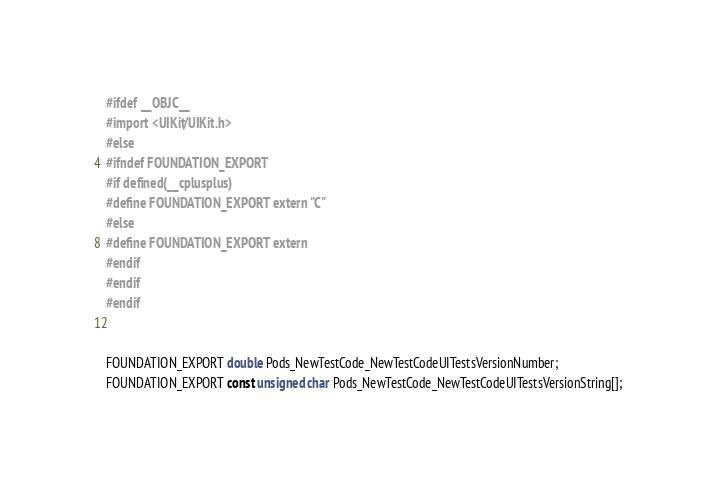Convert code to text. <code><loc_0><loc_0><loc_500><loc_500><_C_>#ifdef __OBJC__
#import <UIKit/UIKit.h>
#else
#ifndef FOUNDATION_EXPORT
#if defined(__cplusplus)
#define FOUNDATION_EXPORT extern "C"
#else
#define FOUNDATION_EXPORT extern
#endif
#endif
#endif


FOUNDATION_EXPORT double Pods_NewTestCode_NewTestCodeUITestsVersionNumber;
FOUNDATION_EXPORT const unsigned char Pods_NewTestCode_NewTestCodeUITestsVersionString[];

</code> 